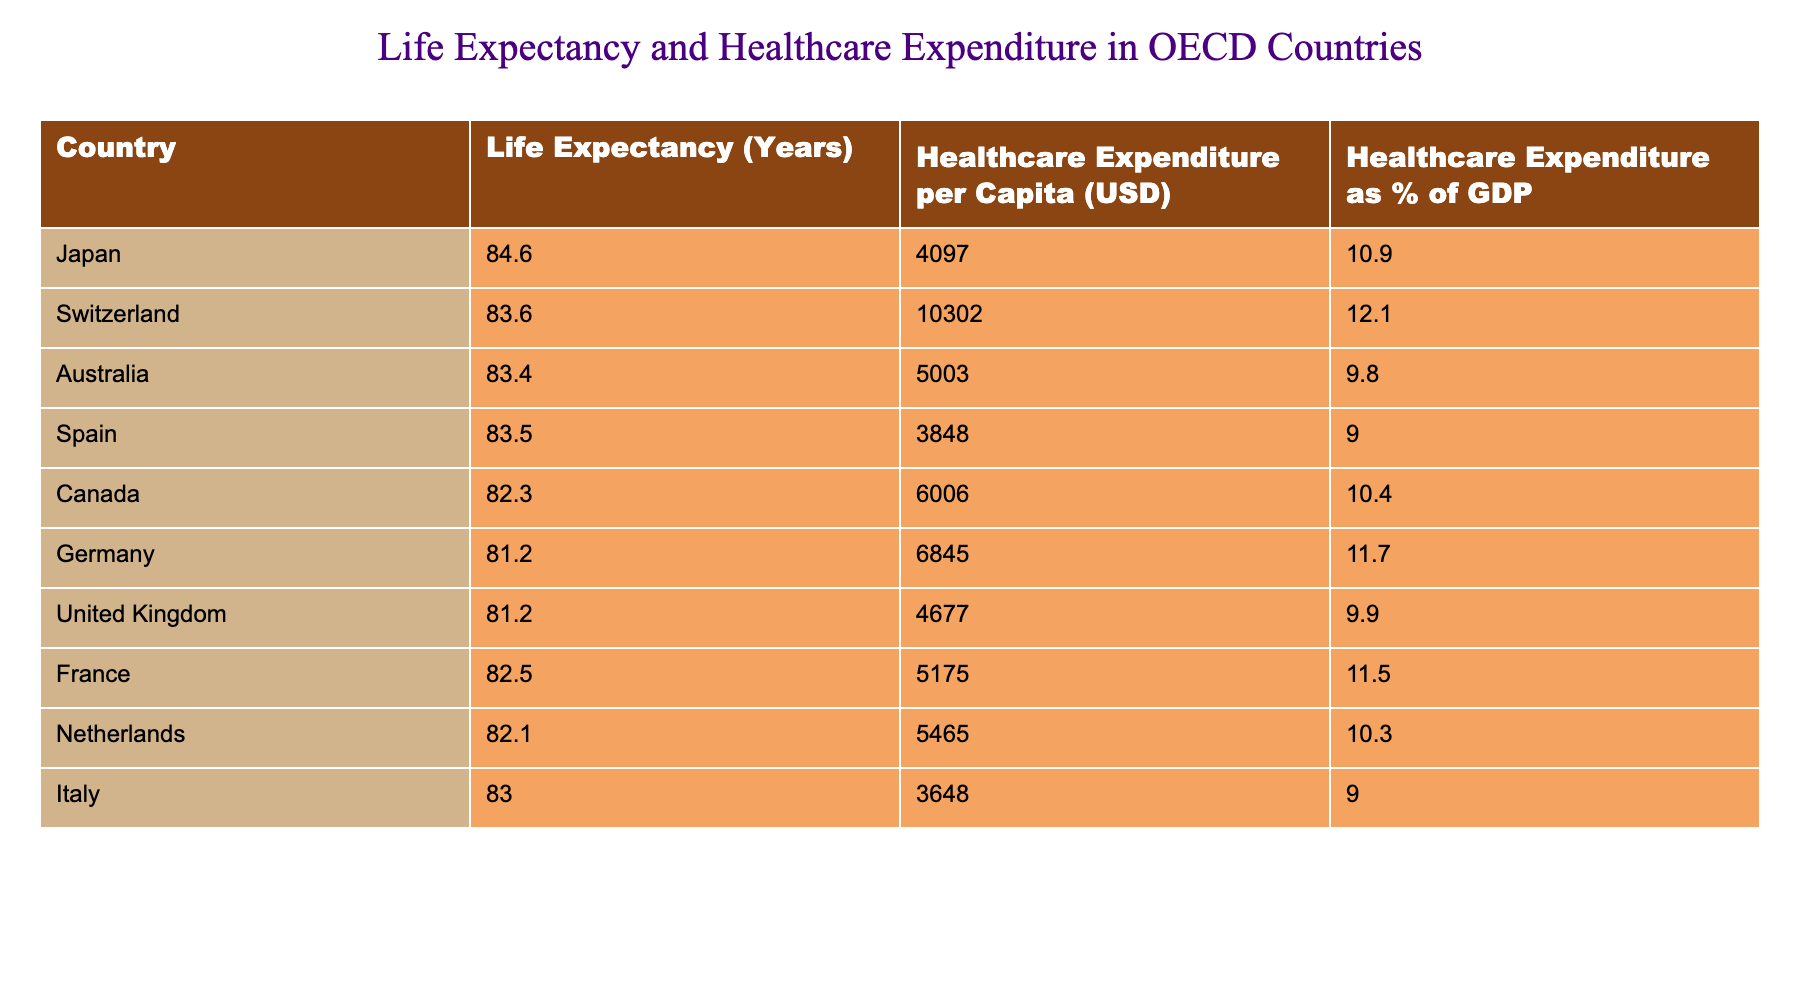What is the life expectancy of Japan? The life expectancy of Japan is listed directly in the first row of the table, where it shows 84.6 years.
Answer: 84.6 years Which country has the highest healthcare expenditure per capita? By examining the second column of the table, Switzerland has the highest healthcare expenditure per capita at 10,302 USD.
Answer: Switzerland What is the average life expectancy of the countries listed in the table? To calculate the average, sum the life expectancy values: (84.6 + 83.6 + 83.4 + 83.5 + 82.3 + 81.2 + 81.2 + 82.5 + 82.1 + 83.0) = 830.4. There are 10 countries, so the average is 830.4/10 = 83.04 years.
Answer: 83.04 years Is the healthcare expenditure as a percentage of GDP higher in Canada than in Italy? According to the table, Canada has a healthcare expenditure of 10.4% of GDP, while Italy is at 9.0%. Since 10.4% is greater than 9.0%, the answer is yes.
Answer: Yes What is the difference in life expectancy between Japan and Germany? The life expectancy for Japan is 84.6 years and for Germany is 81.2 years. The difference is calculated as 84.6 - 81.2 = 3.4 years.
Answer: 3.4 years Which country has a healthcare expenditure percentage closer to 10%: Australia or the United Kingdom? Australia has a healthcare expenditure of 9.8%, while the United Kingdom's is 9.9%. Since 9.9% is closer to 10%, the United Kingdom is the answer.
Answer: United Kingdom How many countries have a life expectancy greater than 82 years? By reviewing the life expectancy column, four countries exceed 82 years: Japan, Switzerland, Australia, and Spain (84.6, 83.6, 83.4, 83.5). Therefore, the total is 4.
Answer: 4 Is the healthcare expenditure per capita in France lower than in Canada? The table shows that France has a healthcare expenditure of 5,175 USD, while Canada has 6,006 USD. Since 5,175 is less than 6,006, it is indeed lower.
Answer: Yes Which has a higher average, healthcare expenditure per capita or life expectancy among the countries? To find this, calculate the average healthcare expenditure per capita (4097 + 10302 + 5003 + 3848 + 6006 + 6845 + 4677 + 5175 + 5465 + 3648) = 48766, and divide by 10 to get an average of 4876.6 USD. The average life expectancy is 83.04 years. Since USD values cannot be directly compared to years, the comparison is not valid, but if just numbers are considered, expenditure is higher.
Answer: Healthcare expenditure is higher 